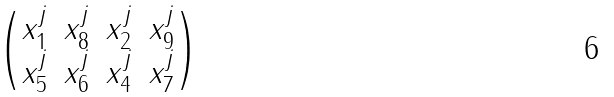Convert formula to latex. <formula><loc_0><loc_0><loc_500><loc_500>\begin{pmatrix} x _ { 1 } ^ { j } & x _ { 8 } ^ { j } & x _ { 2 } ^ { j } & x _ { 9 } ^ { j } \\ x _ { 5 } ^ { j } & x _ { 6 } ^ { j } & x _ { 4 } ^ { j } & x _ { 7 } ^ { j } \end{pmatrix}</formula> 